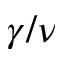<formula> <loc_0><loc_0><loc_500><loc_500>\gamma / \nu</formula> 